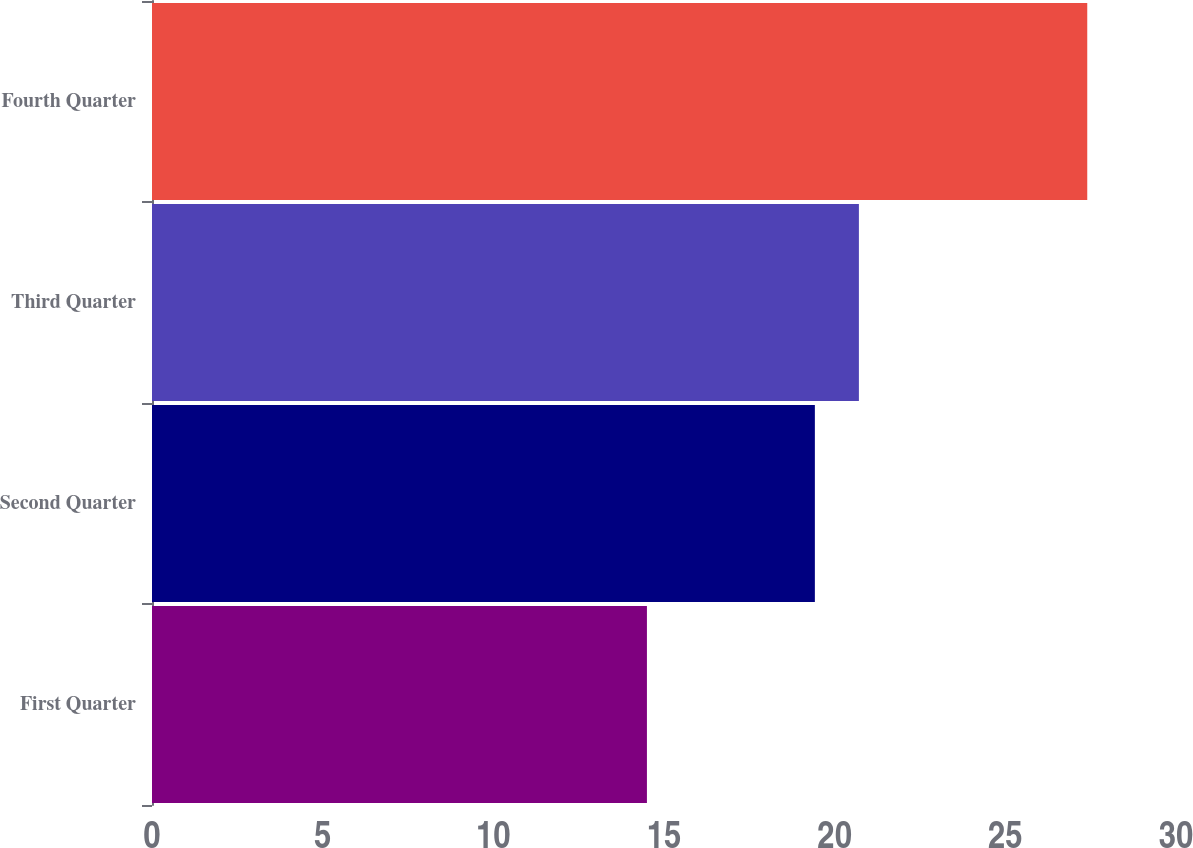Convert chart. <chart><loc_0><loc_0><loc_500><loc_500><bar_chart><fcel>First Quarter<fcel>Second Quarter<fcel>Third Quarter<fcel>Fourth Quarter<nl><fcel>14.5<fcel>19.42<fcel>20.71<fcel>27.4<nl></chart> 